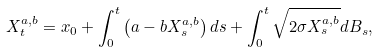Convert formula to latex. <formula><loc_0><loc_0><loc_500><loc_500>X _ { t } ^ { a , b } = x _ { 0 } + \int _ { 0 } ^ { t } \left ( a - b X _ { s } ^ { a , b } \right ) d s + \int _ { 0 } ^ { t } \sqrt { 2 \sigma X _ { s } ^ { a , b } } d B _ { s } ,</formula> 